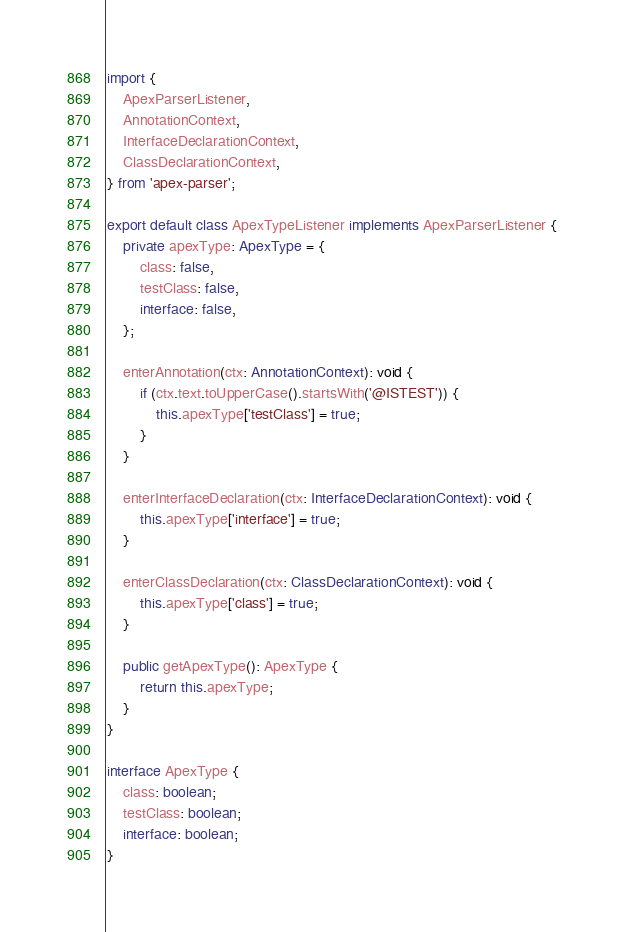Convert code to text. <code><loc_0><loc_0><loc_500><loc_500><_TypeScript_>import {
    ApexParserListener,
    AnnotationContext,
    InterfaceDeclarationContext,
    ClassDeclarationContext,
} from 'apex-parser';

export default class ApexTypeListener implements ApexParserListener {
    private apexType: ApexType = {
        class: false,
        testClass: false,
        interface: false,
    };

    enterAnnotation(ctx: AnnotationContext): void {
        if (ctx.text.toUpperCase().startsWith('@ISTEST')) {
            this.apexType['testClass'] = true;
        }
    }

    enterInterfaceDeclaration(ctx: InterfaceDeclarationContext): void {
        this.apexType['interface'] = true;
    }

    enterClassDeclaration(ctx: ClassDeclarationContext): void {
        this.apexType['class'] = true;
    }

    public getApexType(): ApexType {
        return this.apexType;
    }
}

interface ApexType {
    class: boolean;
    testClass: boolean;
    interface: boolean;
}
</code> 